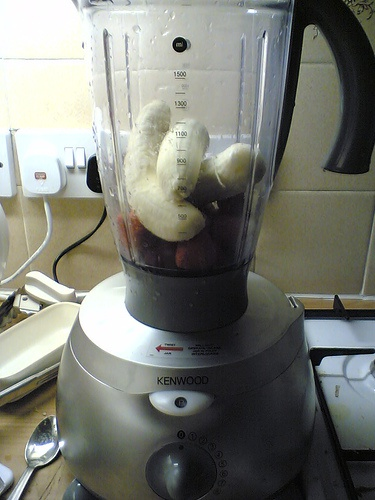Describe the objects in this image and their specific colors. I can see banana in white, darkgray, beige, and gray tones, bowl in white, beige, darkgray, and gray tones, banana in white, darkgray, beige, and gray tones, banana in white, black, gray, darkgreen, and darkgray tones, and spoon in white, darkgray, gray, and black tones in this image. 